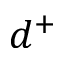Convert formula to latex. <formula><loc_0><loc_0><loc_500><loc_500>d ^ { + }</formula> 